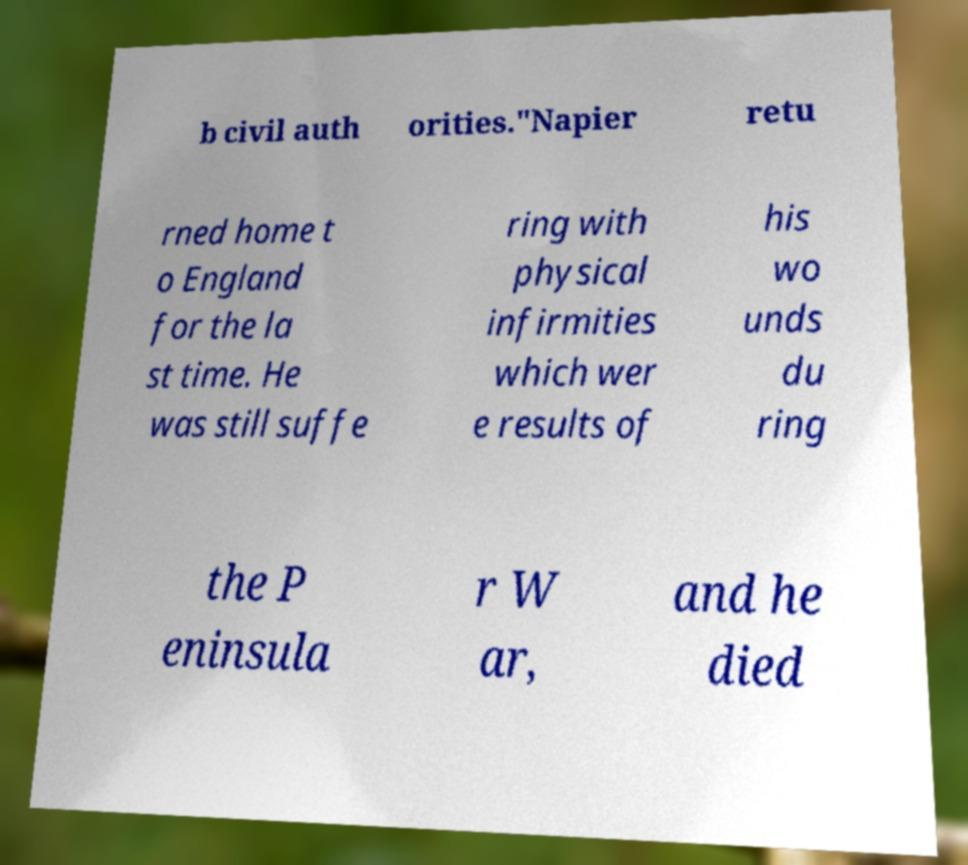There's text embedded in this image that I need extracted. Can you transcribe it verbatim? b civil auth orities."Napier retu rned home t o England for the la st time. He was still suffe ring with physical infirmities which wer e results of his wo unds du ring the P eninsula r W ar, and he died 